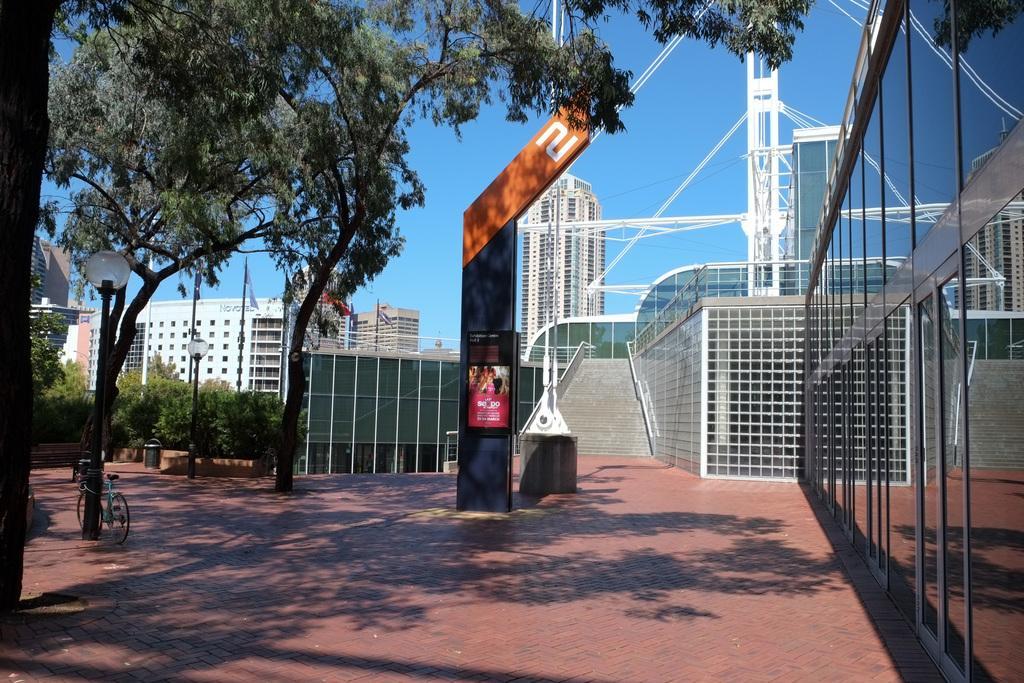Can you describe this image briefly? On the left of the picture I can see trees and left bottom of the picture I can see cycle. Behind the image I can see buildings and in the middle of the image I can see steps. 